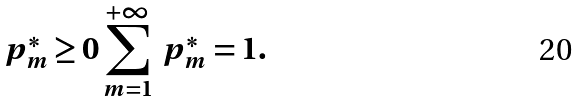<formula> <loc_0><loc_0><loc_500><loc_500>p _ { m } ^ { \ast } \geq 0 \sum _ { m = 1 } ^ { + \infty } \text {\ } p _ { m } ^ { \ast } = 1 .</formula> 